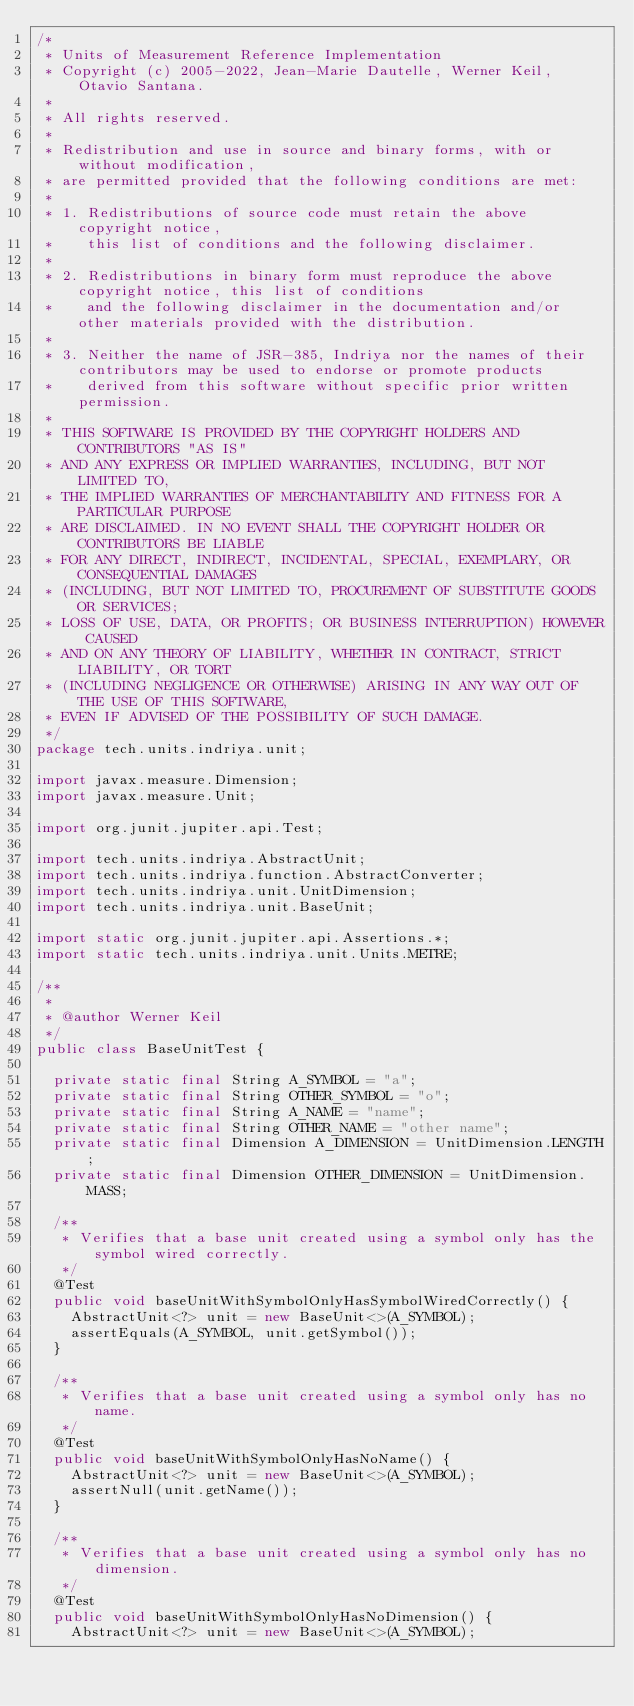Convert code to text. <code><loc_0><loc_0><loc_500><loc_500><_Java_>/*
 * Units of Measurement Reference Implementation
 * Copyright (c) 2005-2022, Jean-Marie Dautelle, Werner Keil, Otavio Santana.
 *
 * All rights reserved.
 *
 * Redistribution and use in source and binary forms, with or without modification,
 * are permitted provided that the following conditions are met:
 *
 * 1. Redistributions of source code must retain the above copyright notice,
 *    this list of conditions and the following disclaimer.
 *
 * 2. Redistributions in binary form must reproduce the above copyright notice, this list of conditions
 *    and the following disclaimer in the documentation and/or other materials provided with the distribution.
 *
 * 3. Neither the name of JSR-385, Indriya nor the names of their contributors may be used to endorse or promote products
 *    derived from this software without specific prior written permission.
 *
 * THIS SOFTWARE IS PROVIDED BY THE COPYRIGHT HOLDERS AND CONTRIBUTORS "AS IS"
 * AND ANY EXPRESS OR IMPLIED WARRANTIES, INCLUDING, BUT NOT LIMITED TO,
 * THE IMPLIED WARRANTIES OF MERCHANTABILITY AND FITNESS FOR A PARTICULAR PURPOSE
 * ARE DISCLAIMED. IN NO EVENT SHALL THE COPYRIGHT HOLDER OR CONTRIBUTORS BE LIABLE
 * FOR ANY DIRECT, INDIRECT, INCIDENTAL, SPECIAL, EXEMPLARY, OR CONSEQUENTIAL DAMAGES
 * (INCLUDING, BUT NOT LIMITED TO, PROCUREMENT OF SUBSTITUTE GOODS OR SERVICES;
 * LOSS OF USE, DATA, OR PROFITS; OR BUSINESS INTERRUPTION) HOWEVER CAUSED
 * AND ON ANY THEORY OF LIABILITY, WHETHER IN CONTRACT, STRICT LIABILITY, OR TORT
 * (INCLUDING NEGLIGENCE OR OTHERWISE) ARISING IN ANY WAY OUT OF THE USE OF THIS SOFTWARE,
 * EVEN IF ADVISED OF THE POSSIBILITY OF SUCH DAMAGE.
 */
package tech.units.indriya.unit;

import javax.measure.Dimension;
import javax.measure.Unit;

import org.junit.jupiter.api.Test;

import tech.units.indriya.AbstractUnit;
import tech.units.indriya.function.AbstractConverter;
import tech.units.indriya.unit.UnitDimension;
import tech.units.indriya.unit.BaseUnit;

import static org.junit.jupiter.api.Assertions.*;
import static tech.units.indriya.unit.Units.METRE;

/**
 *
 * @author Werner Keil
 */
public class BaseUnitTest {

  private static final String A_SYMBOL = "a";
  private static final String OTHER_SYMBOL = "o";
  private static final String A_NAME = "name";
  private static final String OTHER_NAME = "other name";
  private static final Dimension A_DIMENSION = UnitDimension.LENGTH;
  private static final Dimension OTHER_DIMENSION = UnitDimension.MASS;

  /**
   * Verifies that a base unit created using a symbol only has the symbol wired correctly.
   */
  @Test
  public void baseUnitWithSymbolOnlyHasSymbolWiredCorrectly() {
    AbstractUnit<?> unit = new BaseUnit<>(A_SYMBOL);
    assertEquals(A_SYMBOL, unit.getSymbol());
  }

  /**
   * Verifies that a base unit created using a symbol only has no name.
   */
  @Test
  public void baseUnitWithSymbolOnlyHasNoName() {
    AbstractUnit<?> unit = new BaseUnit<>(A_SYMBOL);
    assertNull(unit.getName());
  }

  /**
   * Verifies that a base unit created using a symbol only has no dimension.
   */
  @Test
  public void baseUnitWithSymbolOnlyHasNoDimension() {
    AbstractUnit<?> unit = new BaseUnit<>(A_SYMBOL);</code> 